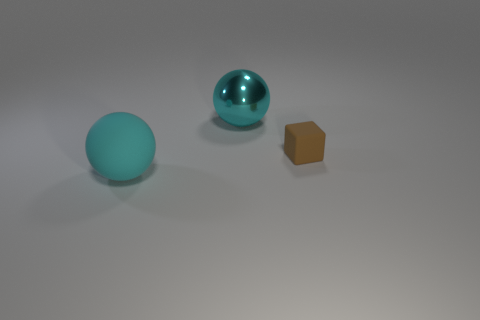There is another large thing that is the same shape as the large rubber object; what is its material?
Your response must be concise. Metal. What color is the sphere that is to the left of the large object that is behind the large sphere that is on the left side of the metal object?
Keep it short and to the point. Cyan. What number of other things are there of the same material as the small object
Your answer should be very brief. 1. There is a big thing in front of the small block; does it have the same shape as the large cyan metal thing?
Give a very brief answer. Yes. What number of large things are matte cubes or purple cubes?
Your response must be concise. 0. Are there an equal number of rubber things that are behind the tiny block and large objects that are right of the large cyan shiny object?
Provide a succinct answer. Yes. How many other things are the same color as the block?
Ensure brevity in your answer.  0. Does the rubber ball have the same color as the rubber object behind the cyan rubber sphere?
Your answer should be compact. No. What number of gray objects are either matte blocks or rubber balls?
Your answer should be very brief. 0. Are there an equal number of large cyan shiny balls in front of the large cyan shiny thing and large cyan matte things?
Make the answer very short. No. 